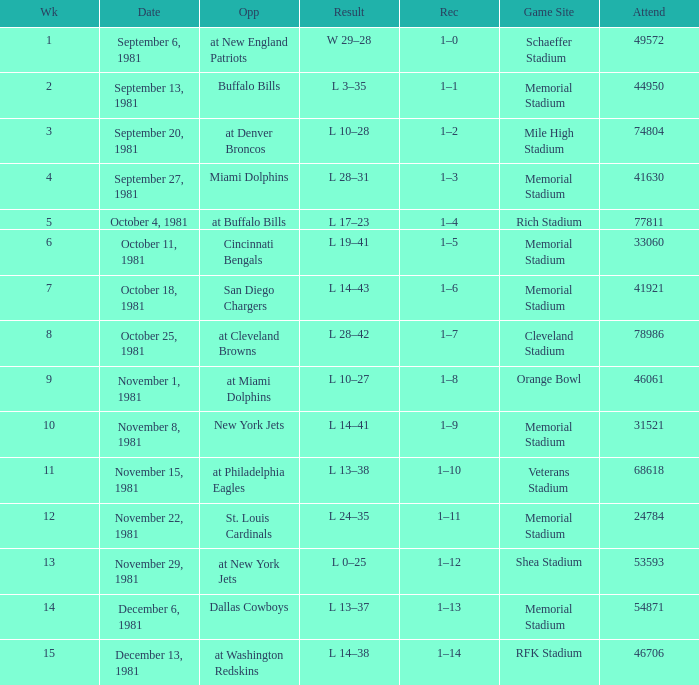When it is October 25, 1981 who is the opponent? At cleveland browns. 